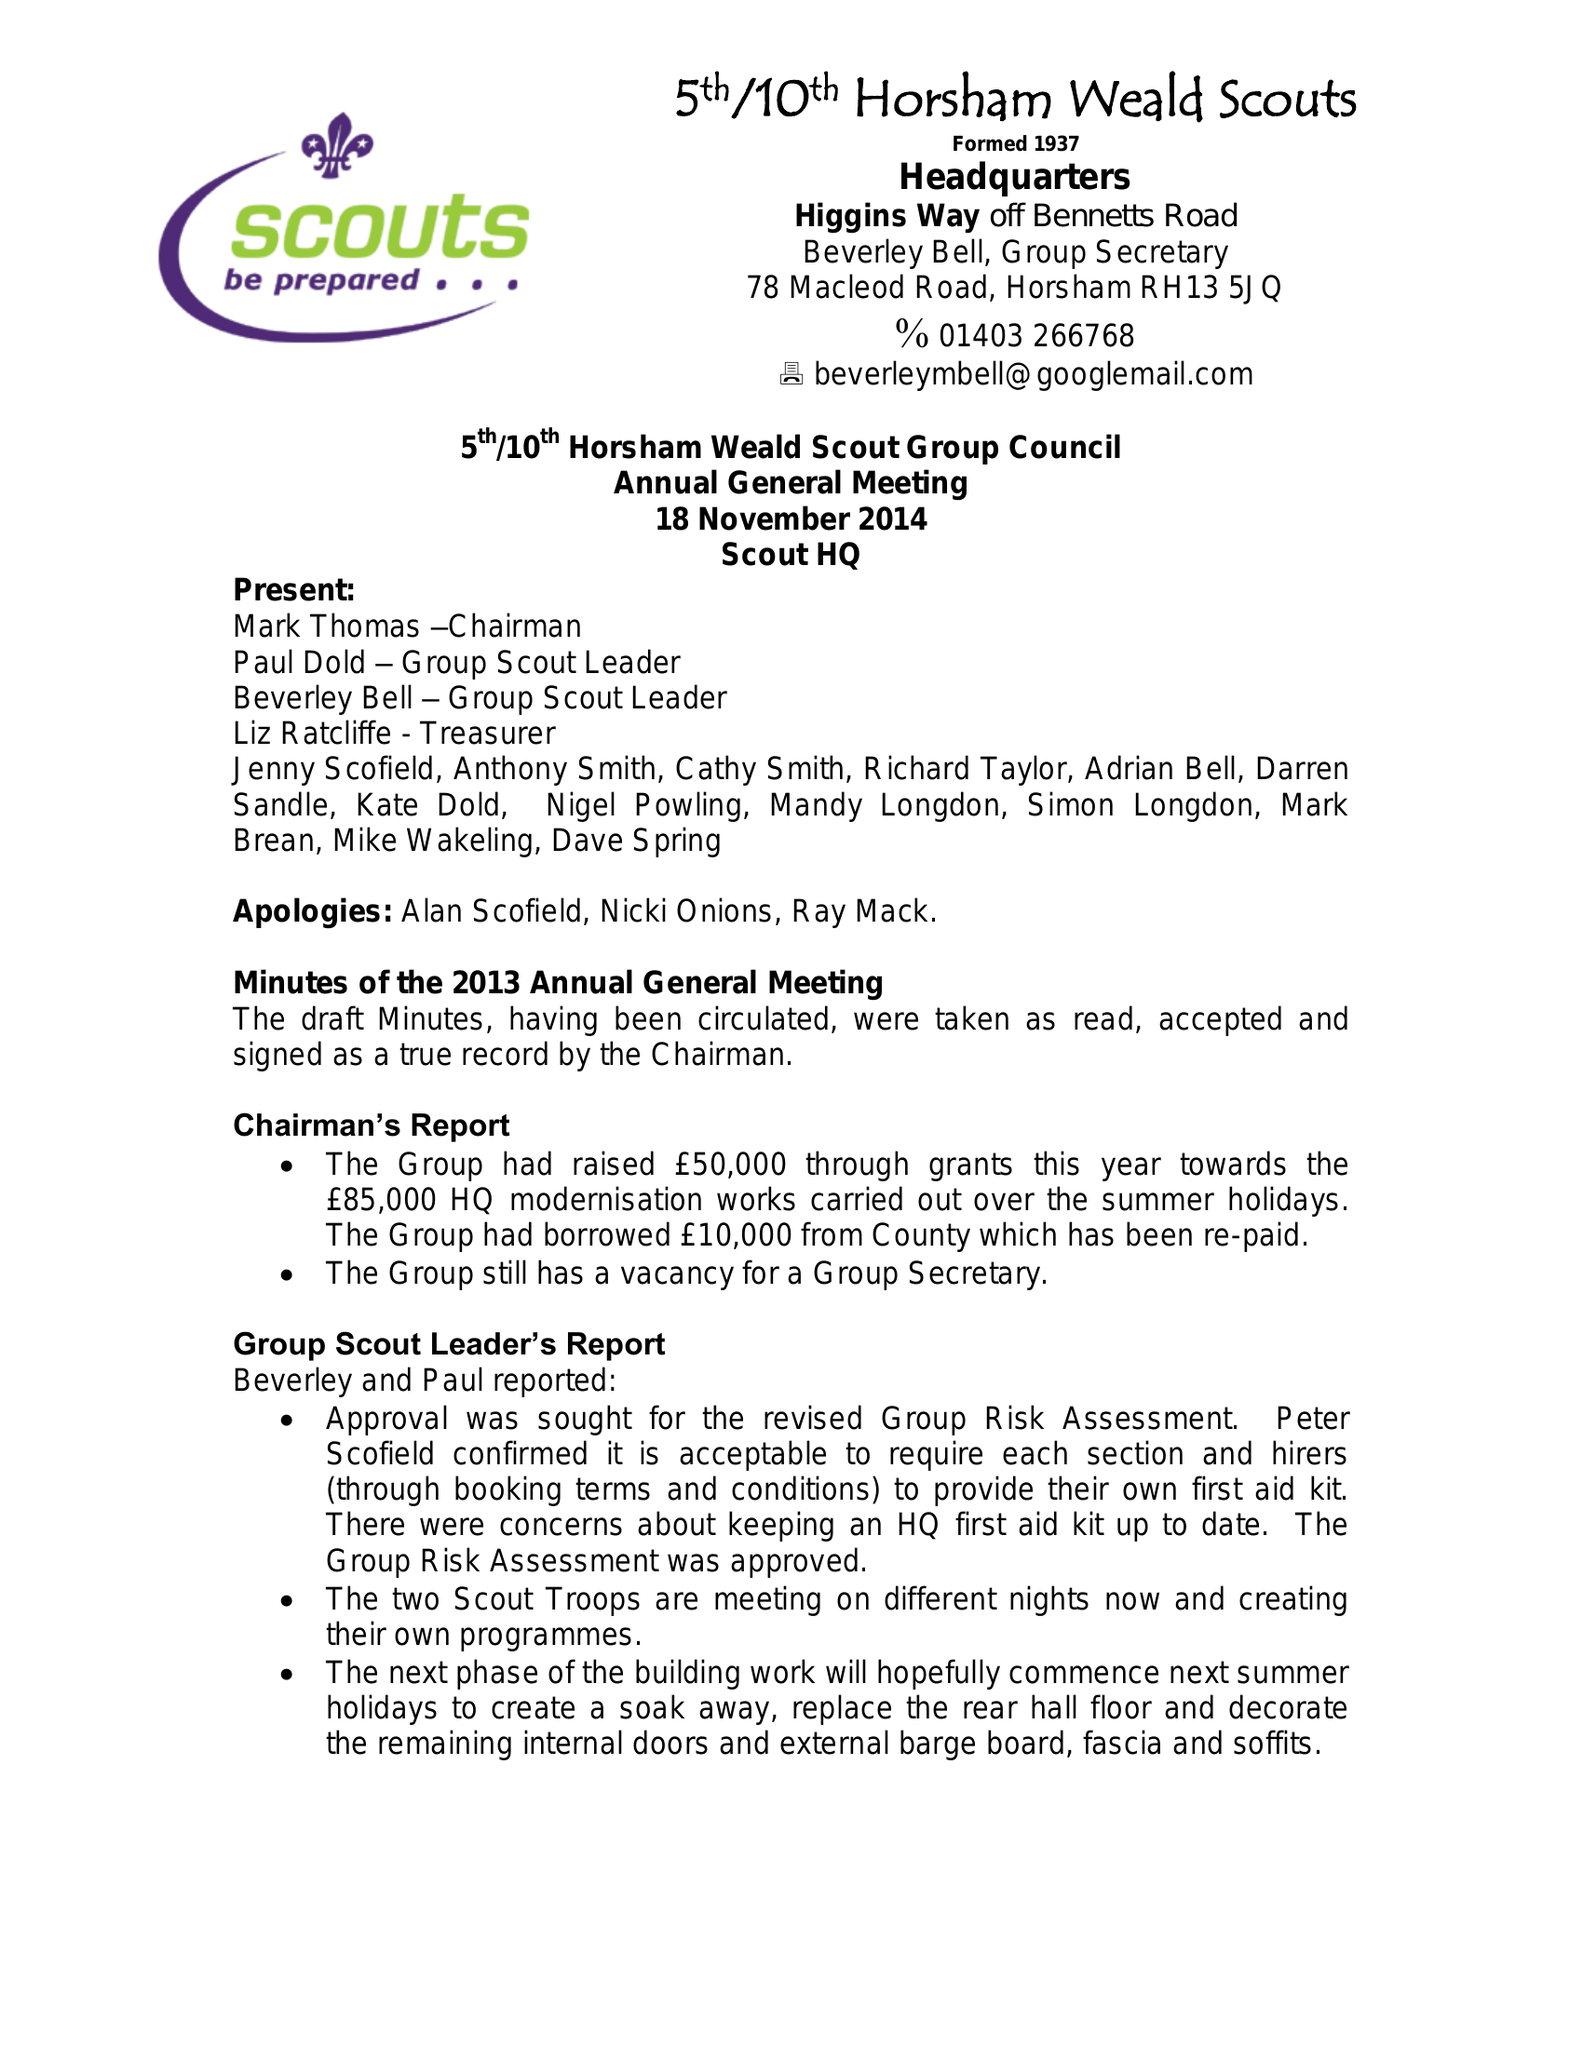What is the value for the address__post_town?
Answer the question using a single word or phrase. HORSHAM 